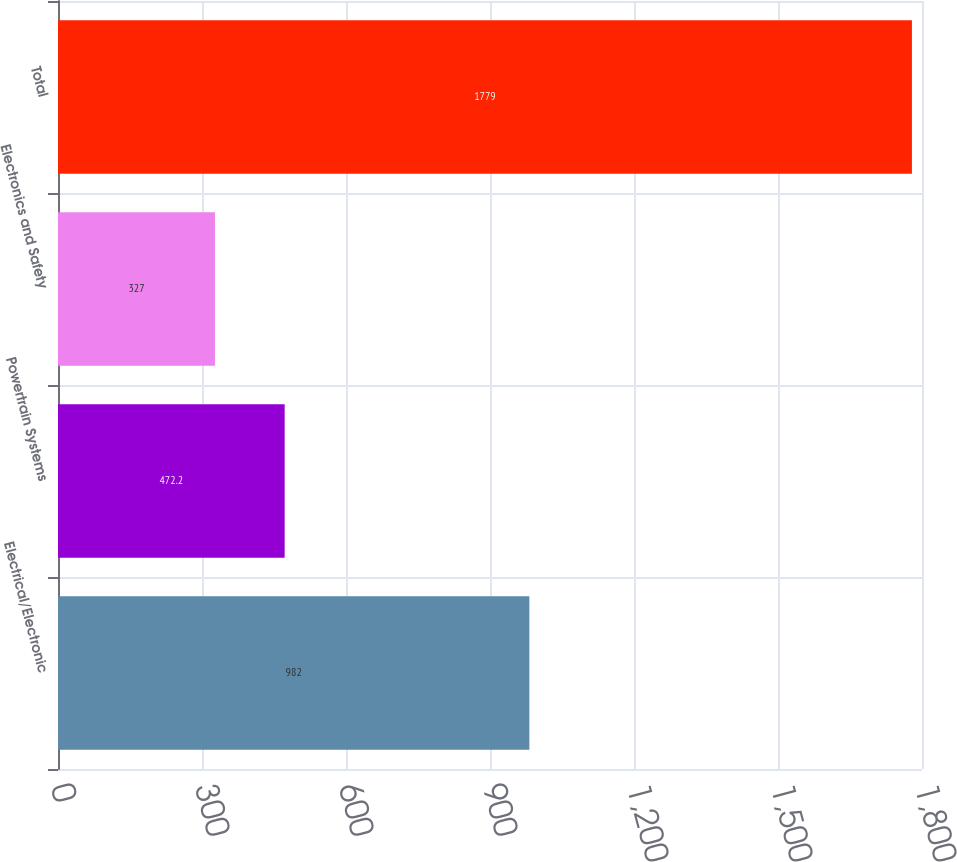Convert chart to OTSL. <chart><loc_0><loc_0><loc_500><loc_500><bar_chart><fcel>Electrical/Electronic<fcel>Powertrain Systems<fcel>Electronics and Safety<fcel>Total<nl><fcel>982<fcel>472.2<fcel>327<fcel>1779<nl></chart> 